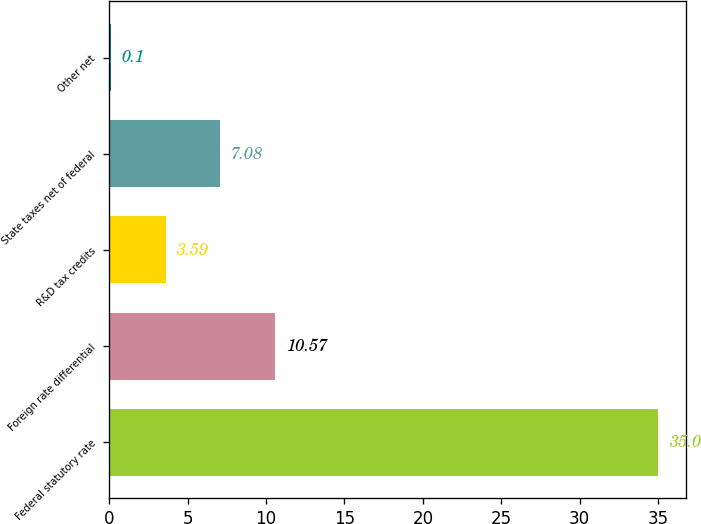Convert chart. <chart><loc_0><loc_0><loc_500><loc_500><bar_chart><fcel>Federal statutory rate<fcel>Foreign rate differential<fcel>R&D tax credits<fcel>State taxes net of federal<fcel>Other net<nl><fcel>35<fcel>10.57<fcel>3.59<fcel>7.08<fcel>0.1<nl></chart> 